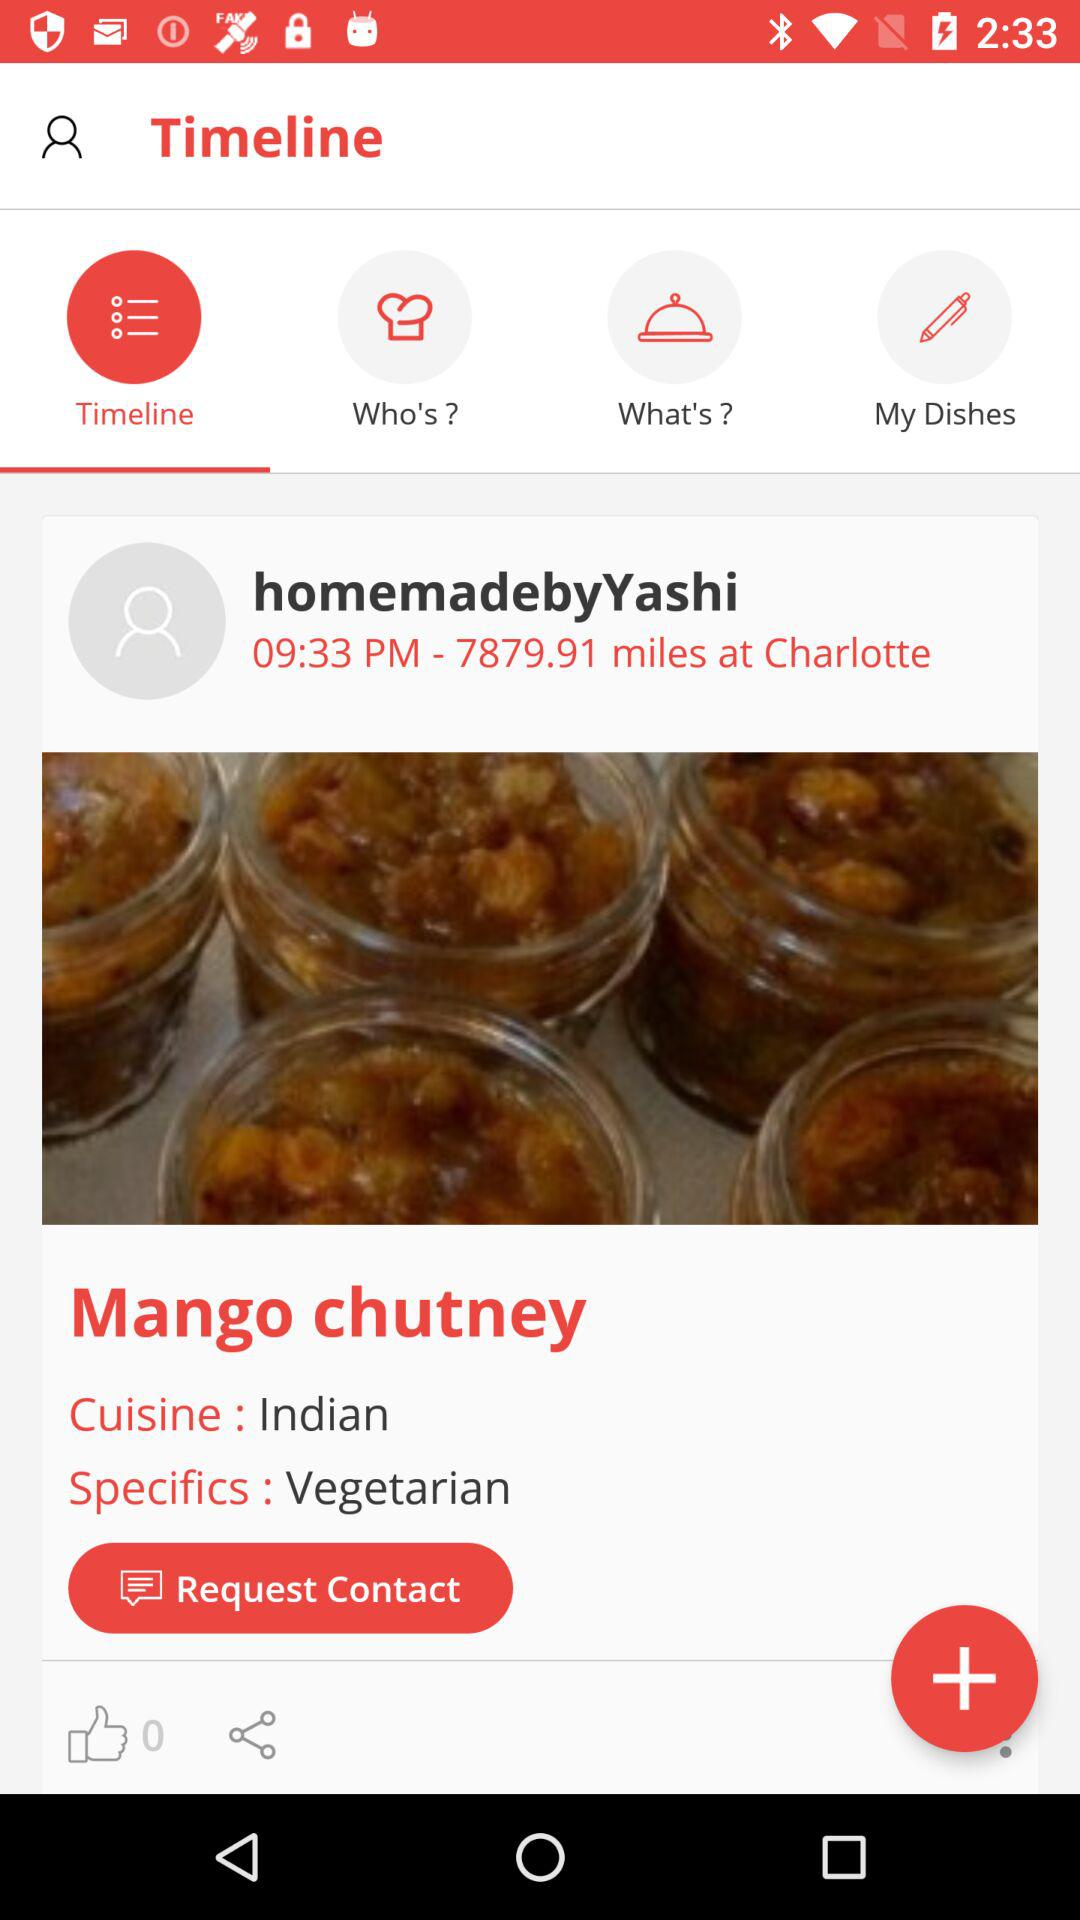How many more thumbs up does the dish have than shares?
Answer the question using a single word or phrase. 0 